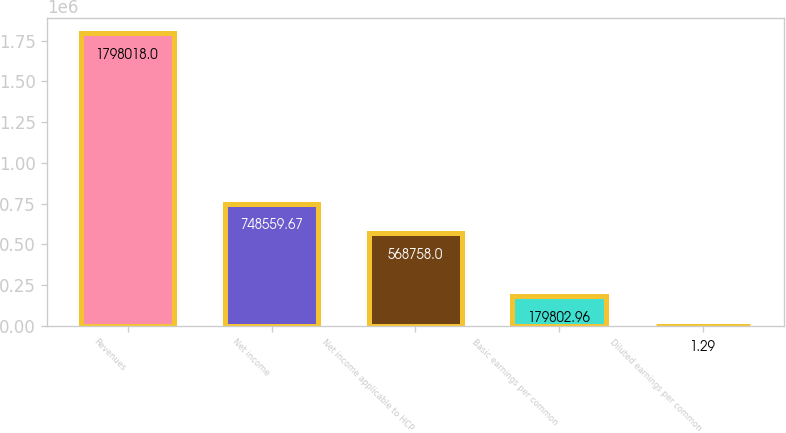Convert chart. <chart><loc_0><loc_0><loc_500><loc_500><bar_chart><fcel>Revenues<fcel>Net income<fcel>Net income applicable to HCP<fcel>Basic earnings per common<fcel>Diluted earnings per common<nl><fcel>1.79802e+06<fcel>748560<fcel>568758<fcel>179803<fcel>1.29<nl></chart> 